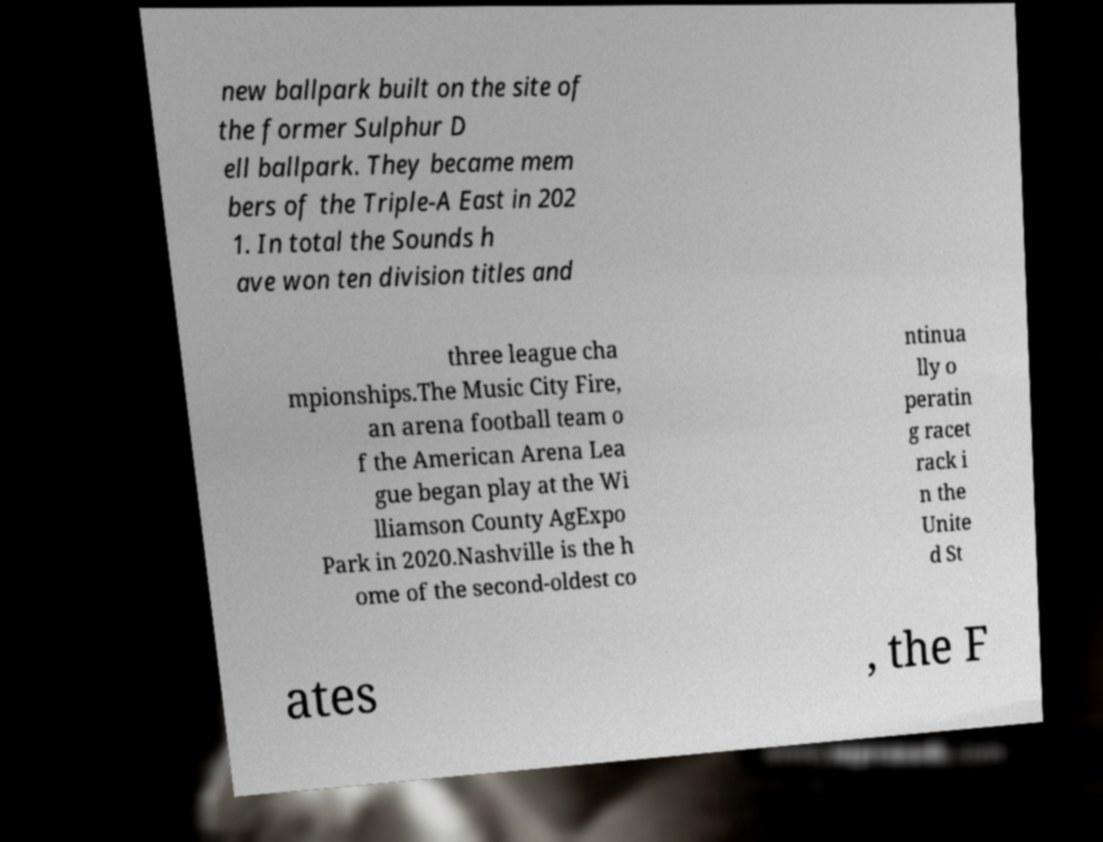Could you assist in decoding the text presented in this image and type it out clearly? new ballpark built on the site of the former Sulphur D ell ballpark. They became mem bers of the Triple-A East in 202 1. In total the Sounds h ave won ten division titles and three league cha mpionships.The Music City Fire, an arena football team o f the American Arena Lea gue began play at the Wi lliamson County AgExpo Park in 2020.Nashville is the h ome of the second-oldest co ntinua lly o peratin g racet rack i n the Unite d St ates , the F 